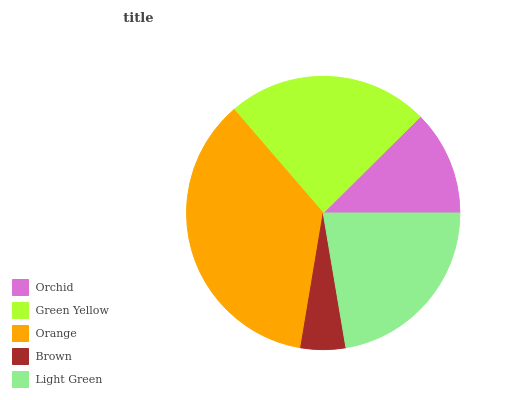Is Brown the minimum?
Answer yes or no. Yes. Is Orange the maximum?
Answer yes or no. Yes. Is Green Yellow the minimum?
Answer yes or no. No. Is Green Yellow the maximum?
Answer yes or no. No. Is Green Yellow greater than Orchid?
Answer yes or no. Yes. Is Orchid less than Green Yellow?
Answer yes or no. Yes. Is Orchid greater than Green Yellow?
Answer yes or no. No. Is Green Yellow less than Orchid?
Answer yes or no. No. Is Light Green the high median?
Answer yes or no. Yes. Is Light Green the low median?
Answer yes or no. Yes. Is Orange the high median?
Answer yes or no. No. Is Orchid the low median?
Answer yes or no. No. 